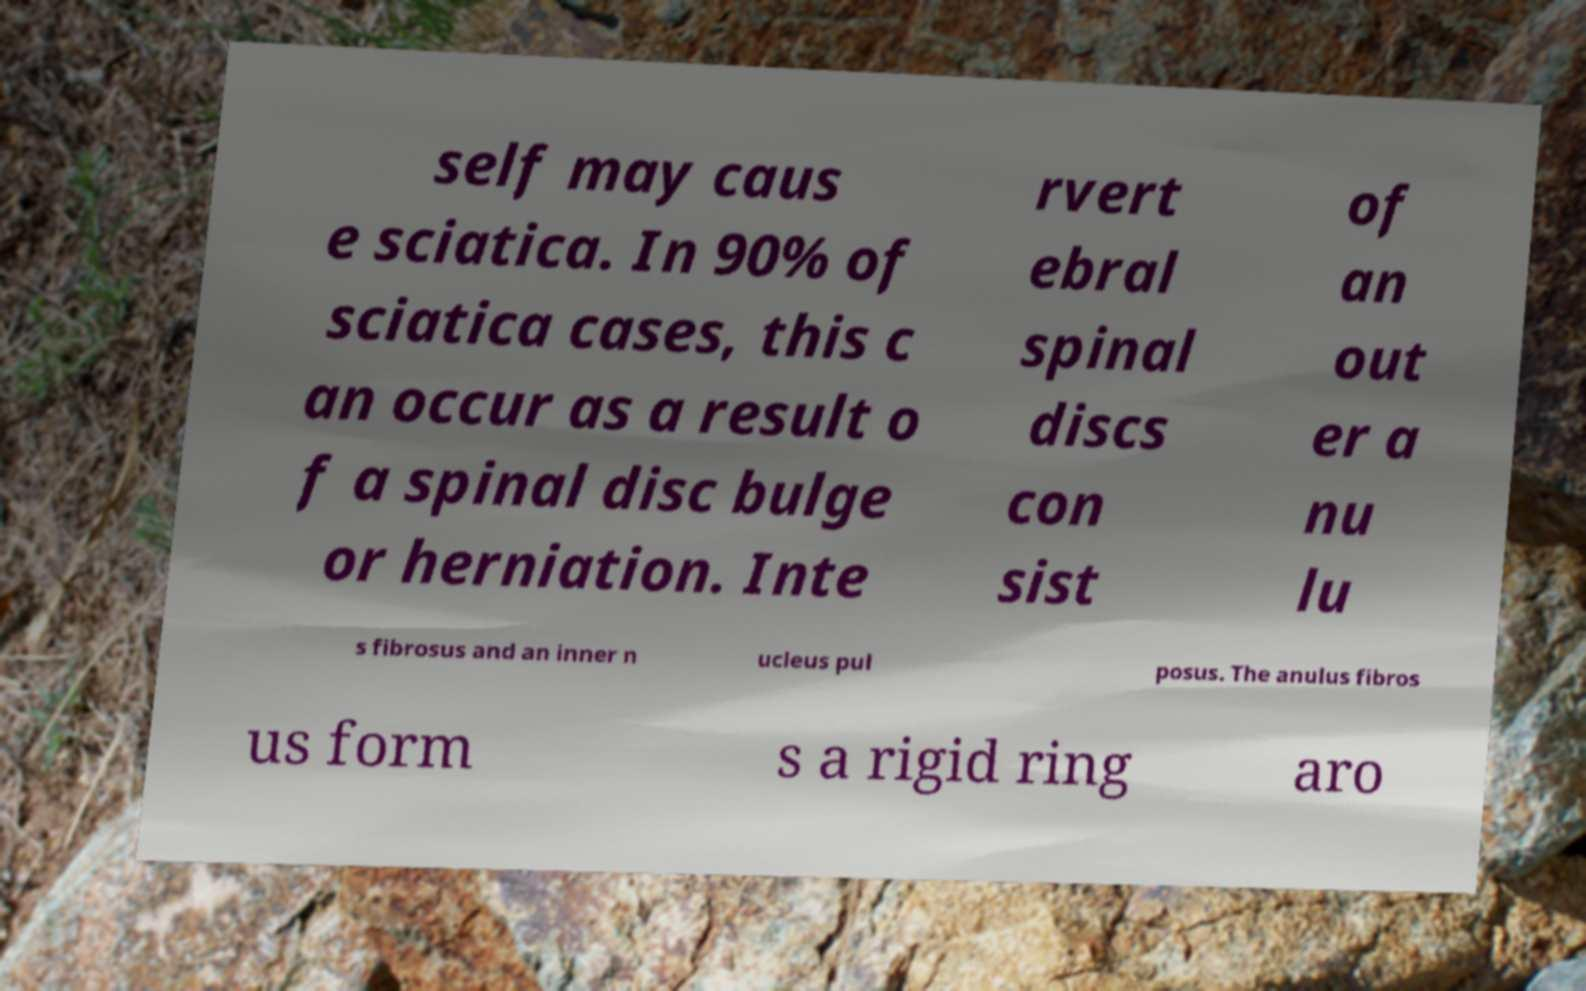There's text embedded in this image that I need extracted. Can you transcribe it verbatim? self may caus e sciatica. In 90% of sciatica cases, this c an occur as a result o f a spinal disc bulge or herniation. Inte rvert ebral spinal discs con sist of an out er a nu lu s fibrosus and an inner n ucleus pul posus. The anulus fibros us form s a rigid ring aro 